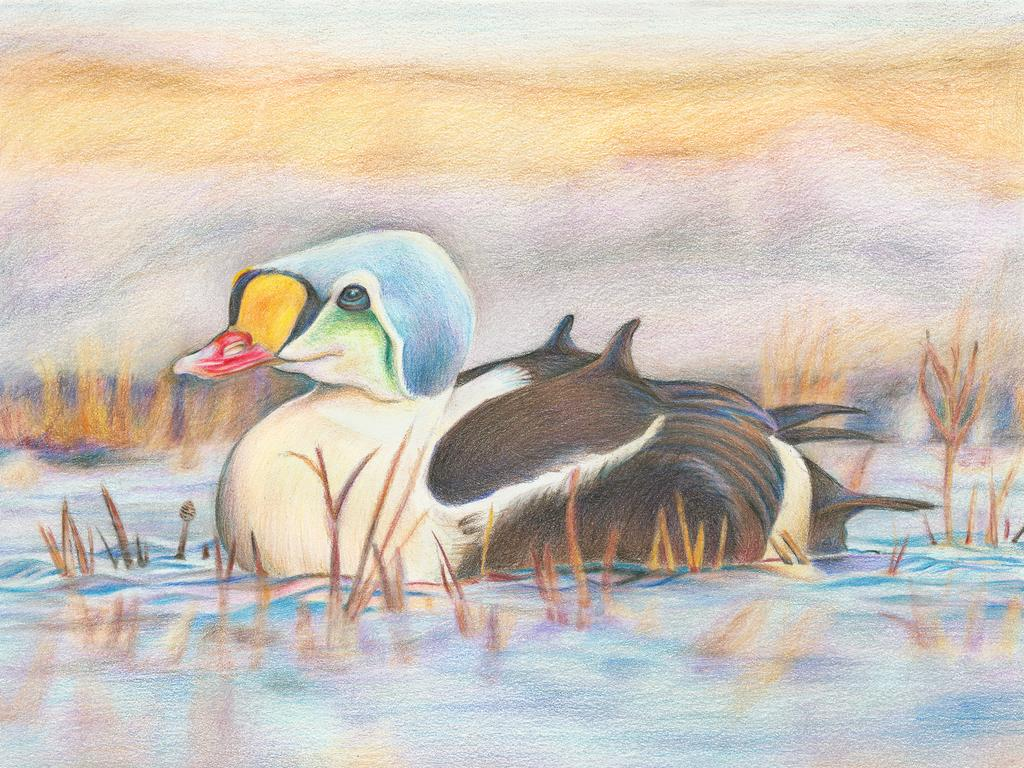What animal is depicted in the drawing? There is a duck in the drawing. What type of vegetation is present in the drawing? There is grass in the drawing. What body of water is shown in the drawing? There is water in the drawing. What type of stamp can be seen on the duck's back in the drawing? There is no stamp present on the duck's back in the drawing. How much butter is spread on the grass in the drawing? There is no butter present in the drawing; it only features a duck, grass, and water. 